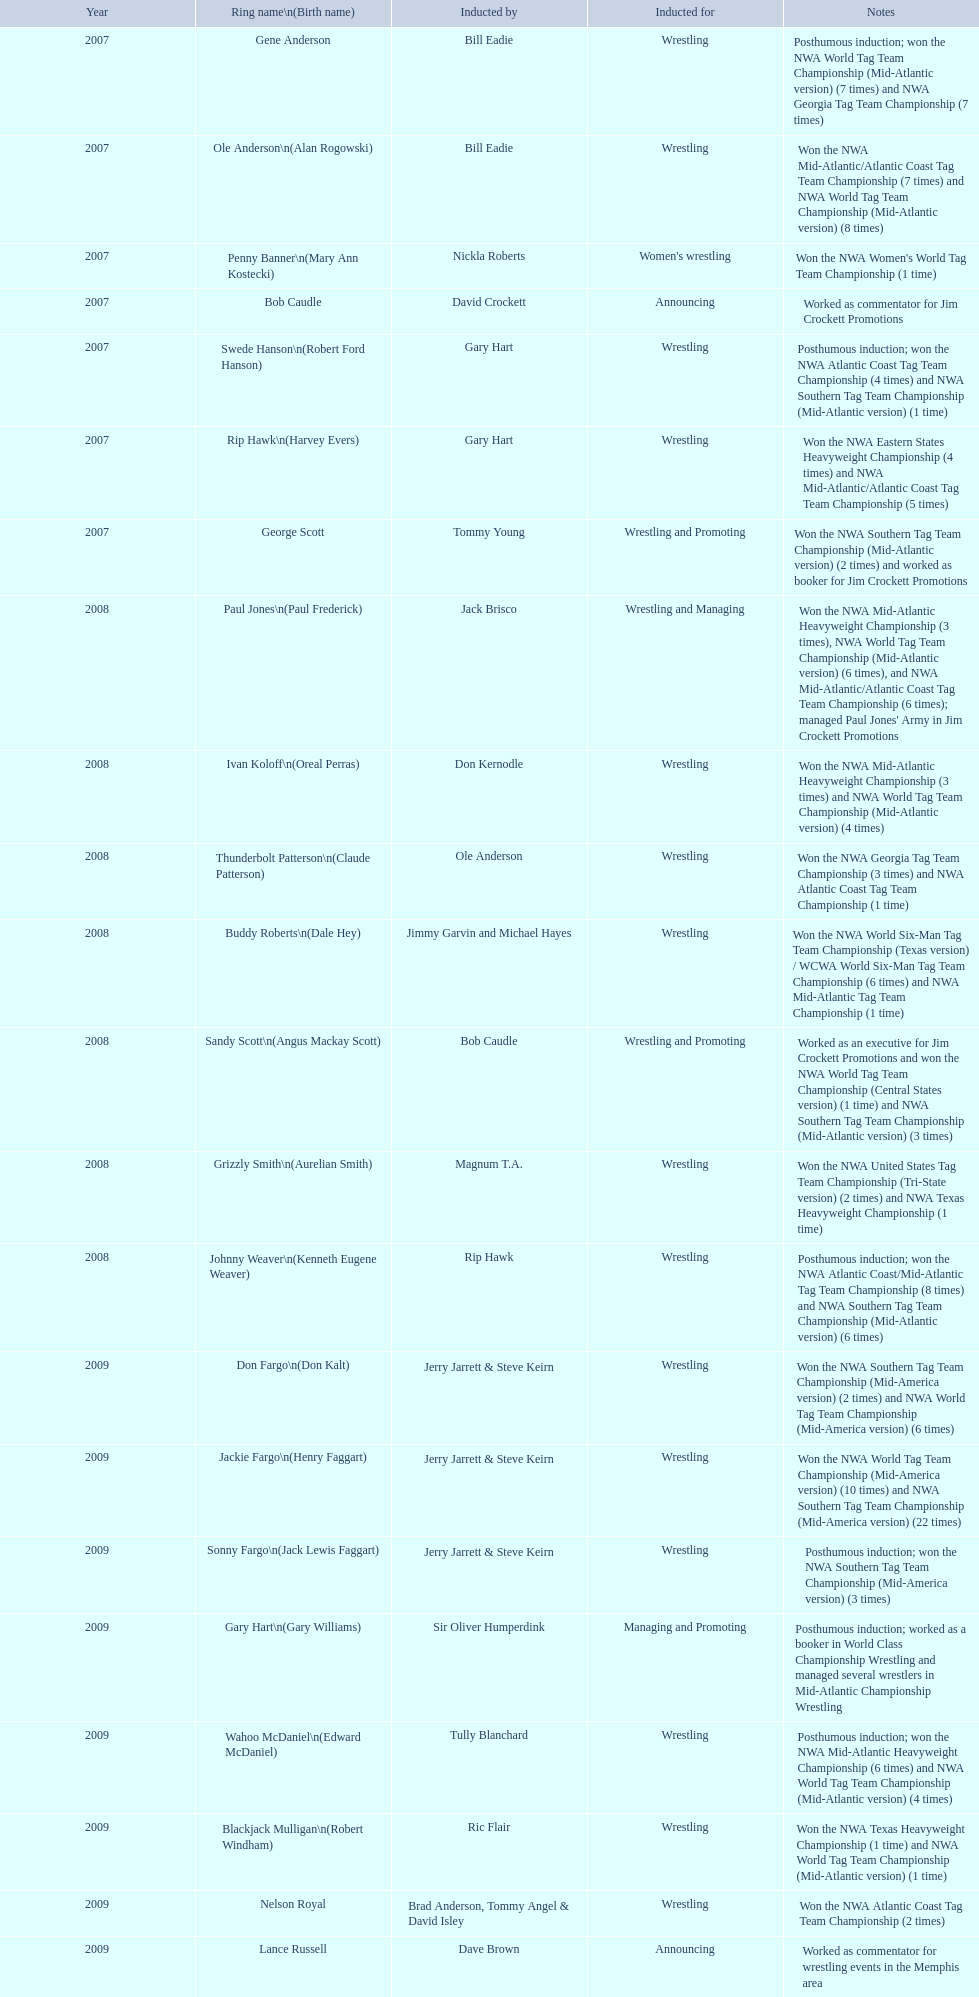What announcers were inducted? Bob Caudle, Lance Russell. What announcer was inducted in 2009? Lance Russell. 